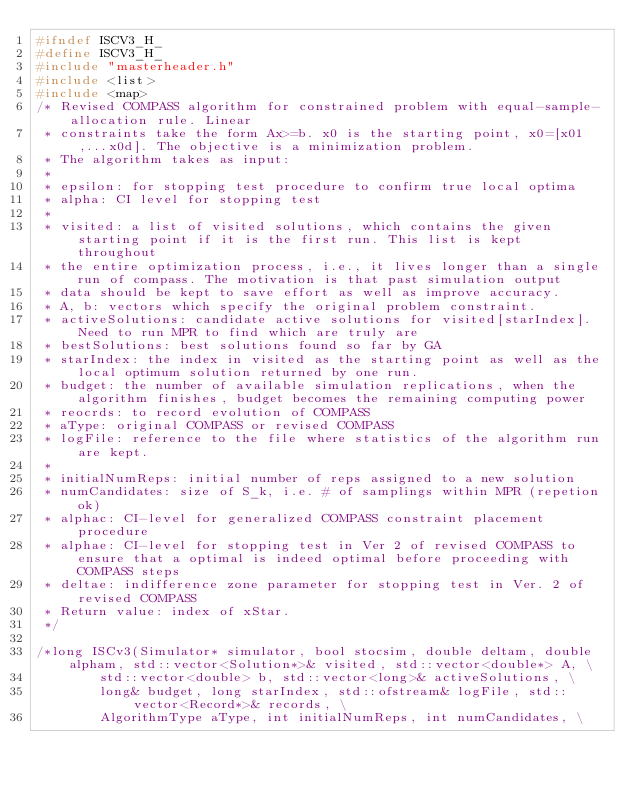<code> <loc_0><loc_0><loc_500><loc_500><_C_>#ifndef ISCV3_H_
#define ISCV3_H_
#include "masterheader.h"
#include <list>
#include <map>
/* Revised COMPASS algorithm for constrained problem with equal-sample-allocation rule. Linear 
 * constraints take the form Ax>=b. x0 is the starting point, x0=[x01,...x0d]. The objective is a minimization problem.
 * The algorithm takes as input:
 * 
 * epsilon: for stopping test procedure to confirm true local optima
 * alpha: CI level for stopping test
 * 
 * visited: a list of visited solutions, which contains the given starting point if it is the first run. This list is kept throughout 
 * the entire optimization process, i.e., it lives longer than a single run of compass. The motivation is that past simulation output 
 * data should be kept to save effort as well as improve accuracy. 
 * A, b: vectors which specify the original problem constraint. 
 * activeSolutions: candidate active solutions for visited[starIndex]. Need to run MPR to find which are truly are
 * bestSolutions: best solutions found so far by GA
 * starIndex: the index in visited as the starting point as well as the local optimum solution returned by one run.
 * budget: the number of available simulation replications, when the algorithm finishes, budget becomes the remaining computing power
 * reocrds: to record evolution of COMPASS
 * aType: original COMPASS or revised COMPASS
 * logFile: reference to the file where statistics of the algorithm run are kept. 
 * 
 * initialNumReps: initial number of reps assigned to a new solution
 * numCandidates: size of S_k, i.e. # of samplings within MPR (repetion ok)
 * alphac: CI-level for generalized COMPASS constraint placement procedure
 * alphae: CI-level for stopping test in Ver 2 of revised COMPASS to ensure that a optimal is indeed optimal before proceeding with COMPASS steps
 * deltae: indifference zone parameter for stopping test in Ver. 2 of revised COMPASS 
 * Return value: index of xStar.
 */

/*long ISCv3(Simulator* simulator, bool stocsim, double deltam, double alpham, std::vector<Solution*>& visited, std::vector<double*> A, \
		std::vector<double> b, std::vector<long>& activeSolutions, \
		long& budget, long starIndex, std::ofstream& logFile, std::vector<Record*>& records, \
		AlgorithmType aType, int initialNumReps, int numCandidates, \</code> 